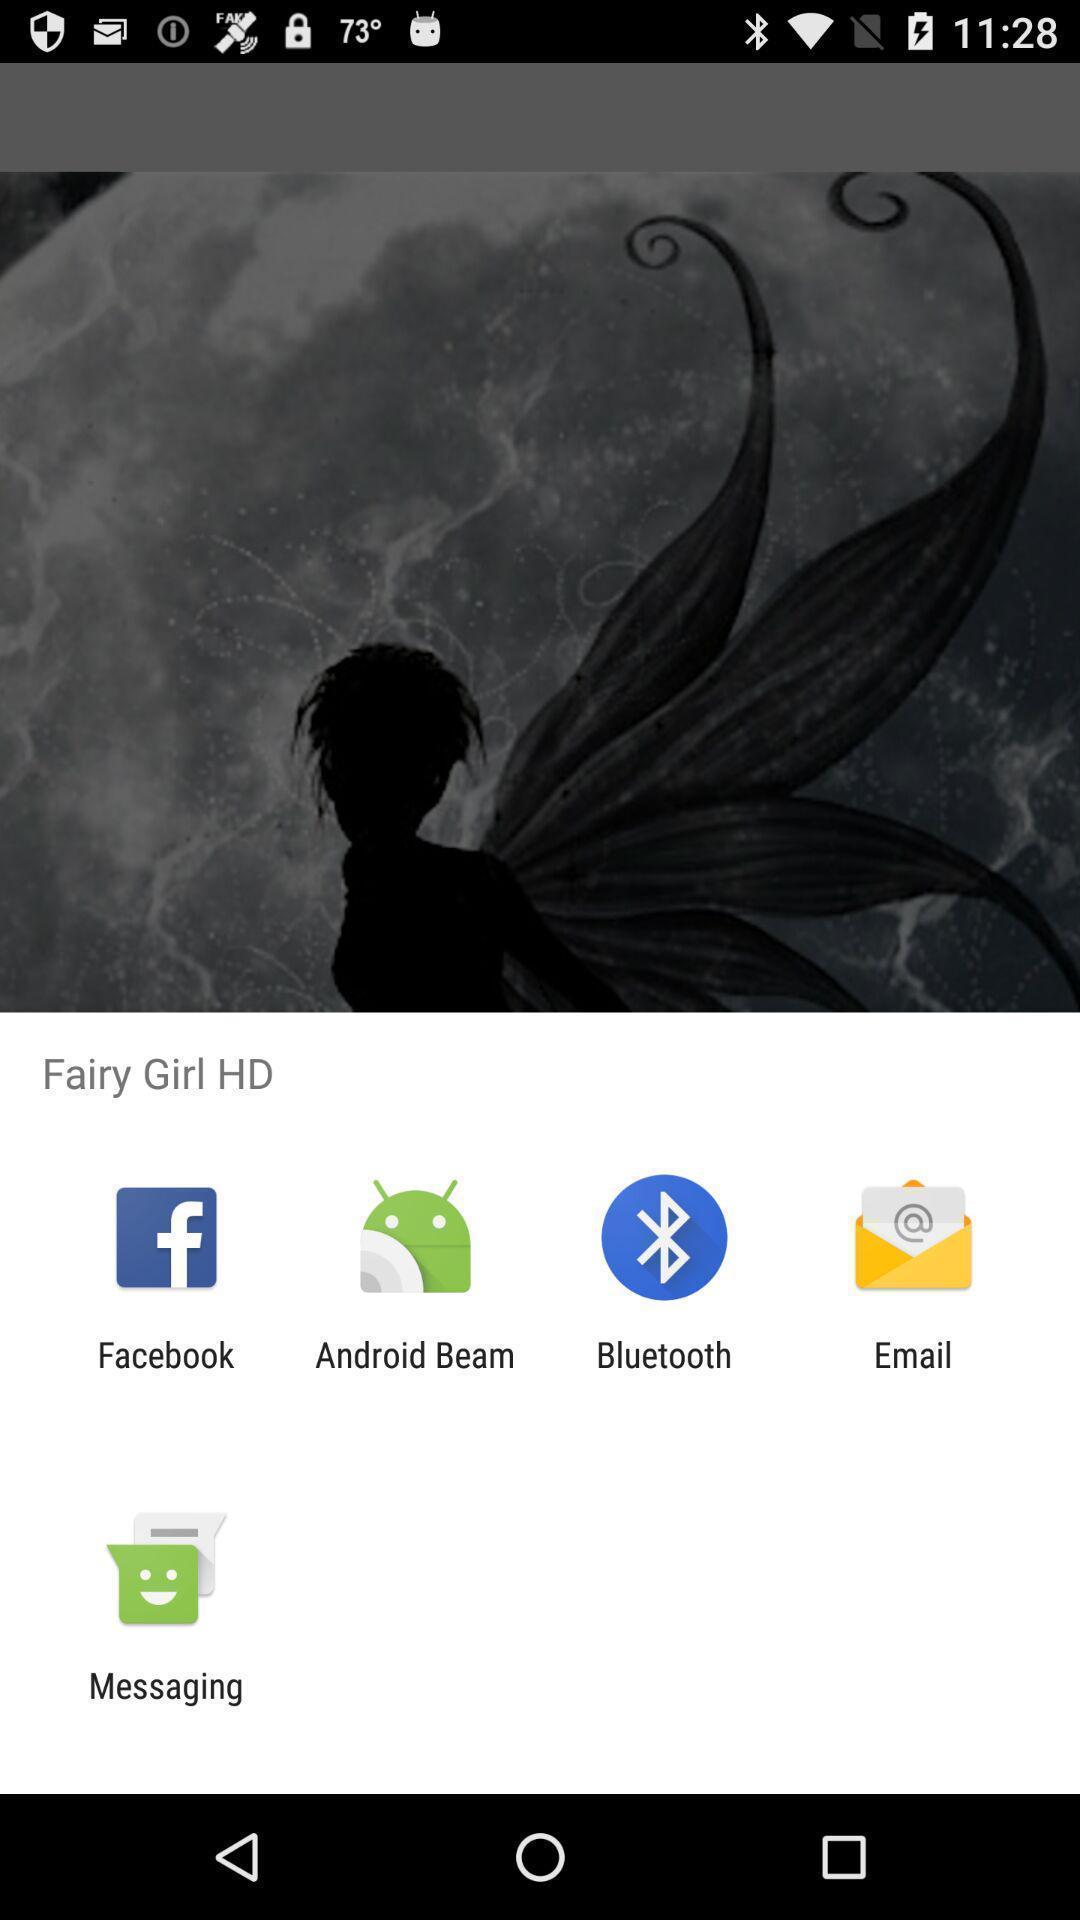Please provide a description for this image. Popup to share an image with different options. 